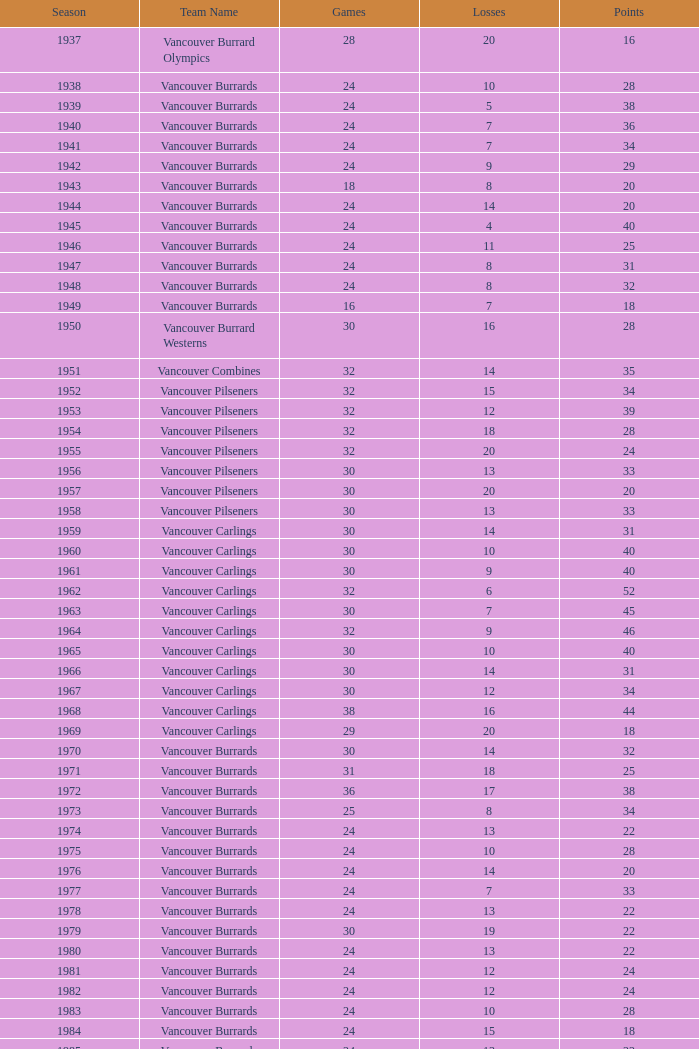What's the complete number of games exceeding 20 points for the 1976 season? 0.0. 